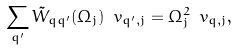Convert formula to latex. <formula><loc_0><loc_0><loc_500><loc_500>\sum _ { q ^ { \prime } } { \tilde { W } } _ { q q ^ { \prime } } ( \Omega _ { j } ) \ v _ { q ^ { \prime } , j } = \Omega ^ { 2 } _ { j } \ v _ { q , j } ,</formula> 